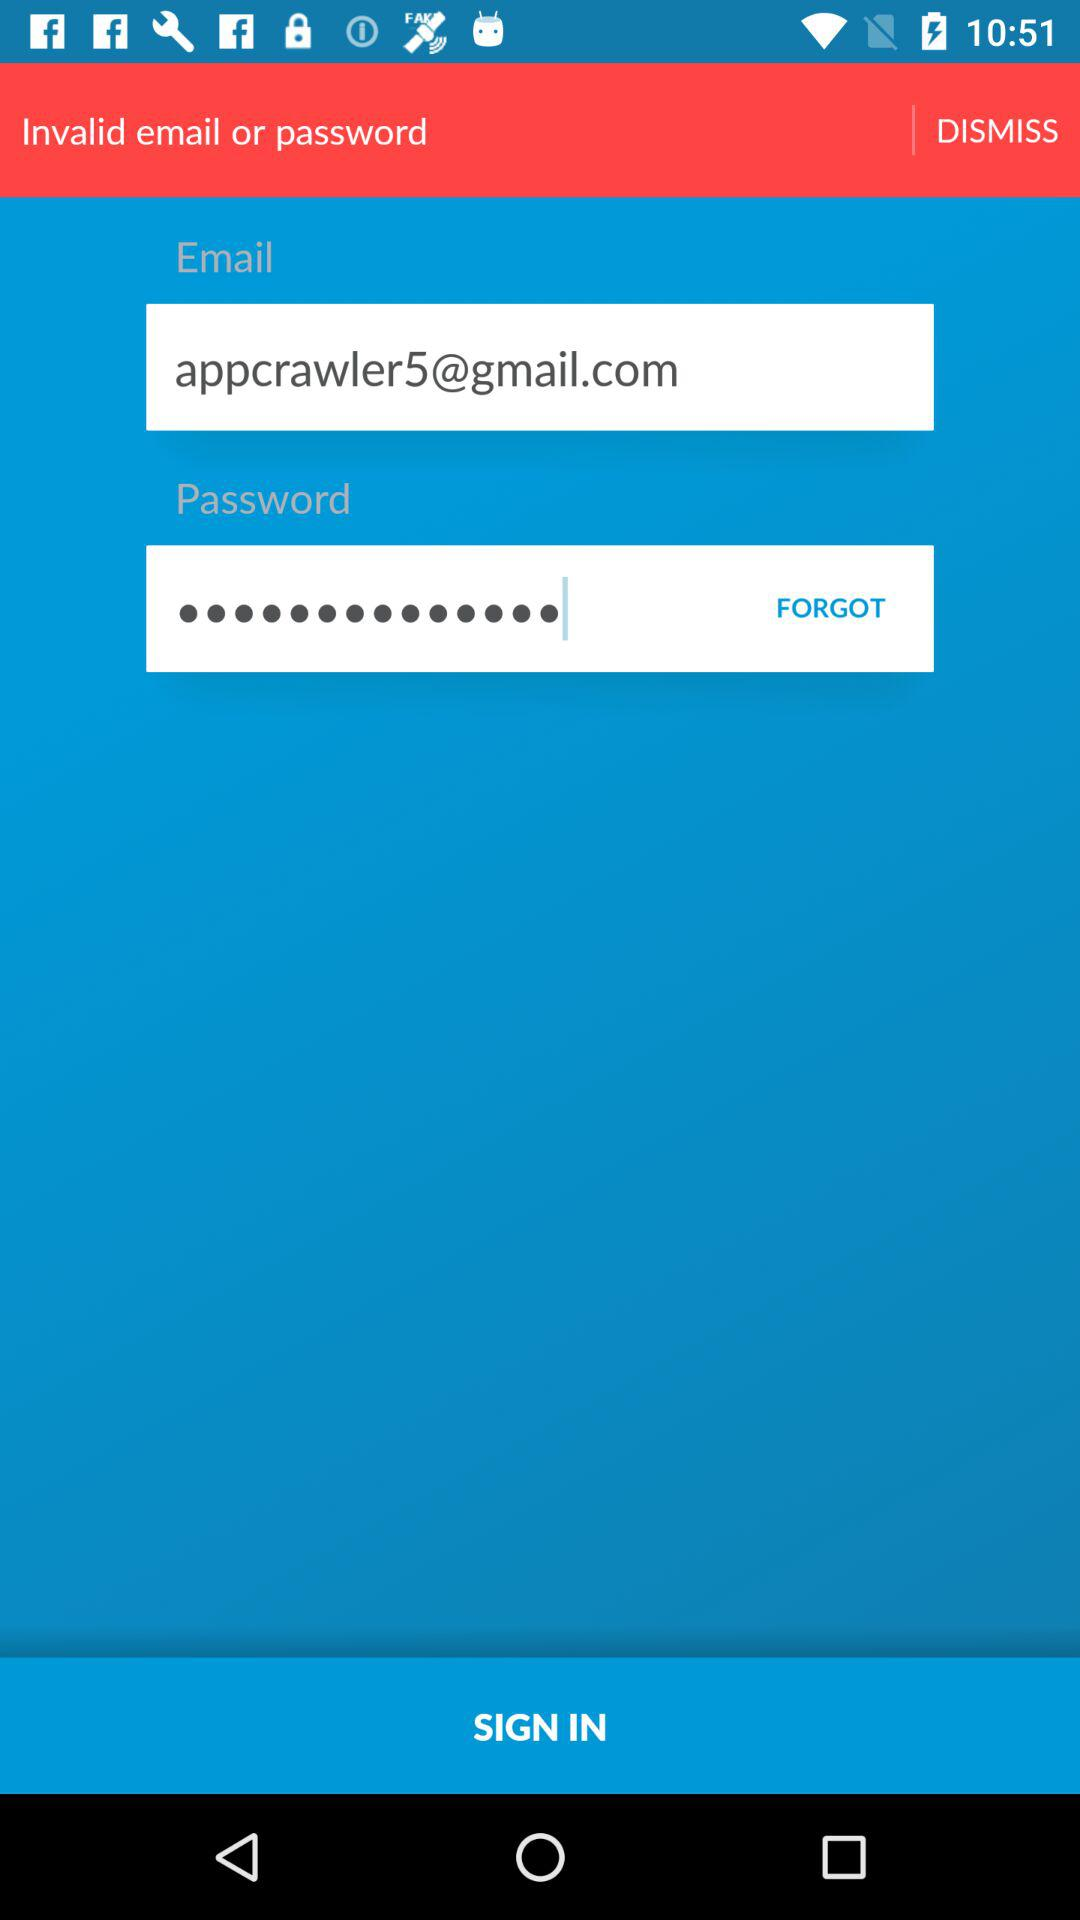How many text inputs are there that are not disabled?
Answer the question using a single word or phrase. 2 